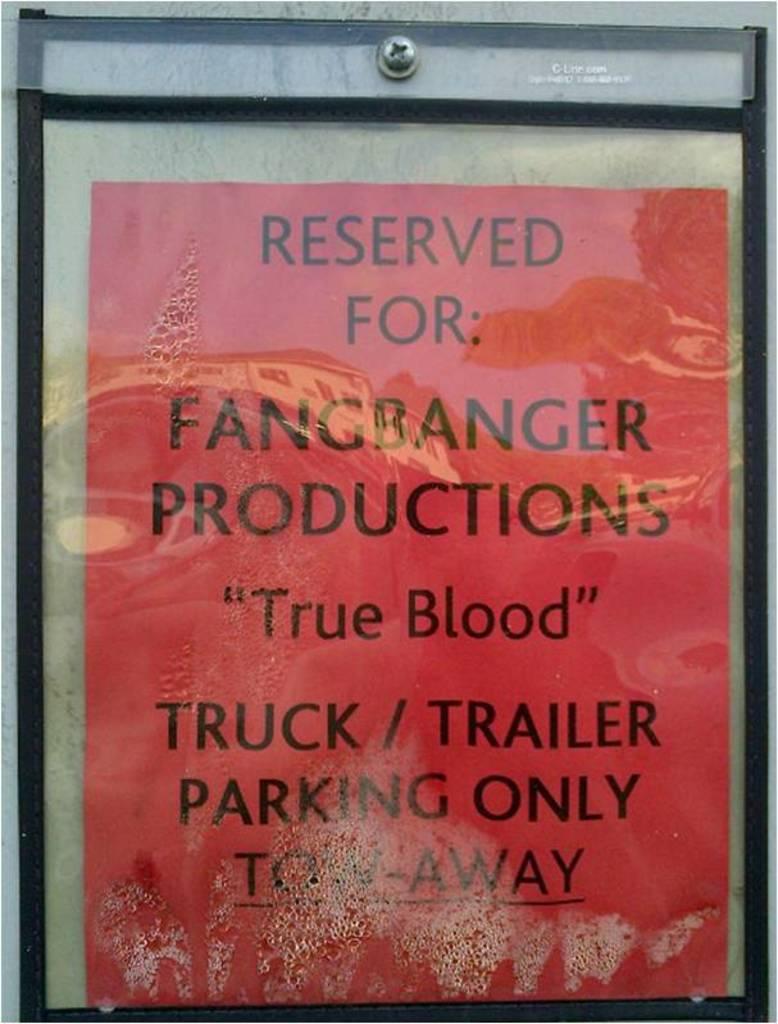What does this sign reserve for?
Your response must be concise. Fangbanger productions . 